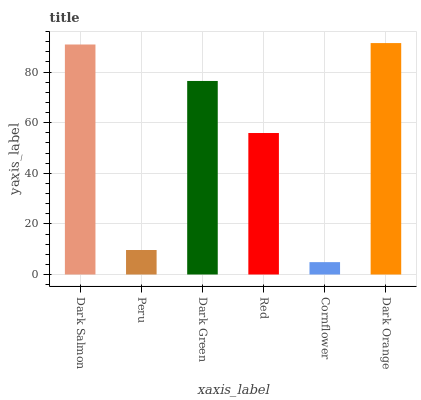Is Peru the minimum?
Answer yes or no. No. Is Peru the maximum?
Answer yes or no. No. Is Dark Salmon greater than Peru?
Answer yes or no. Yes. Is Peru less than Dark Salmon?
Answer yes or no. Yes. Is Peru greater than Dark Salmon?
Answer yes or no. No. Is Dark Salmon less than Peru?
Answer yes or no. No. Is Dark Green the high median?
Answer yes or no. Yes. Is Red the low median?
Answer yes or no. Yes. Is Red the high median?
Answer yes or no. No. Is Peru the low median?
Answer yes or no. No. 